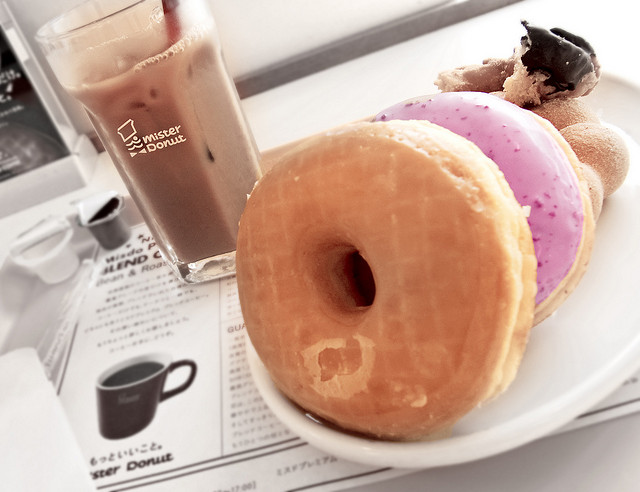Tell me about the atmosphere of the place where this photo was taken. The photo exudes a casual and relaxed atmosphere, typically found in a cozy café. The presence of a menu and branded cup seems to suggest the setting might be part of a donut shop chain. 